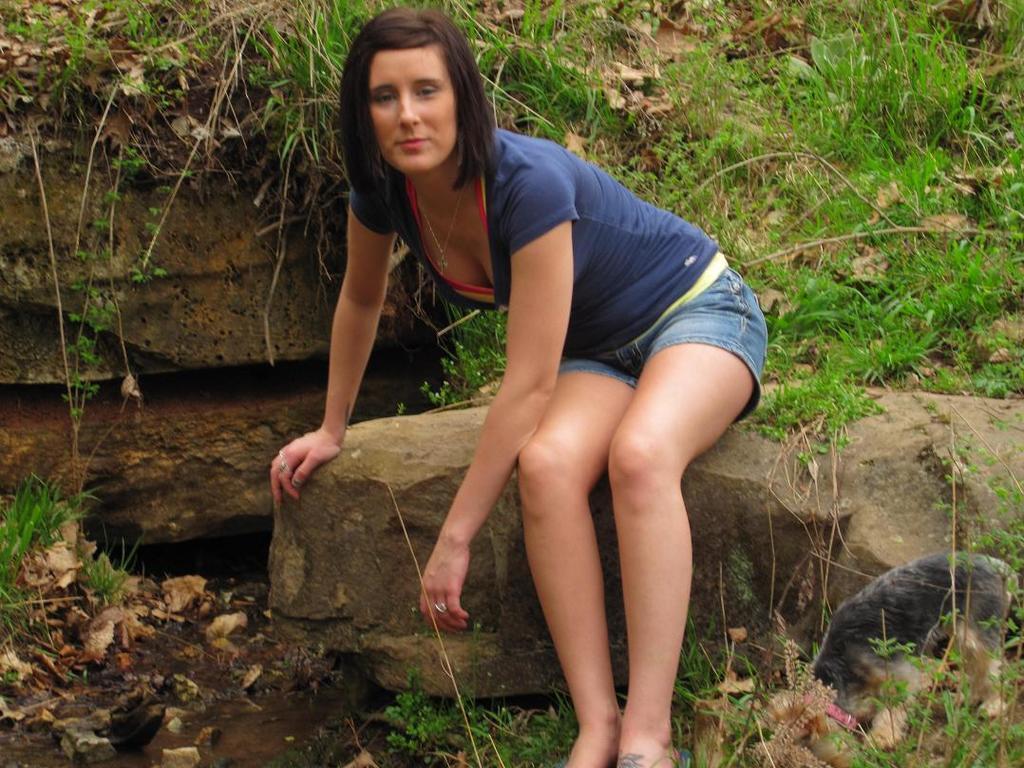How would you summarize this image in a sentence or two? This is the picture of a lady who is wearing the shorts and sitting on the rock and behind there are some other rocks and some plants. 